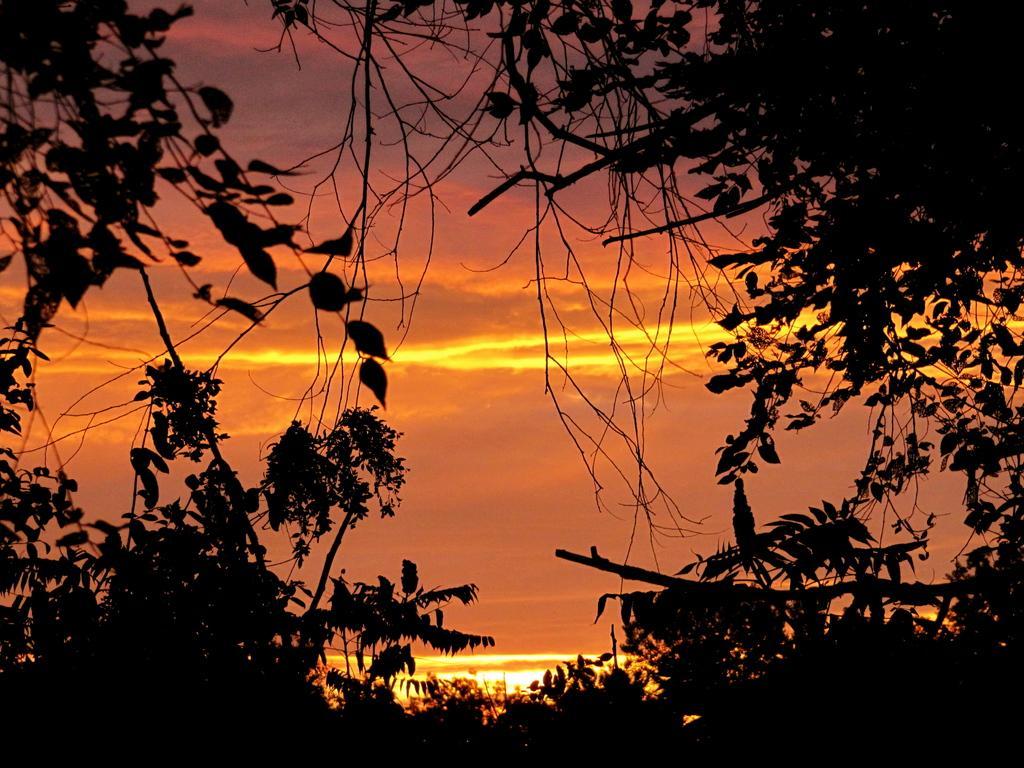In one or two sentences, can you explain what this image depicts? In the background we can see the sky. In this picture we can see the trees, green leaves and the branches. 